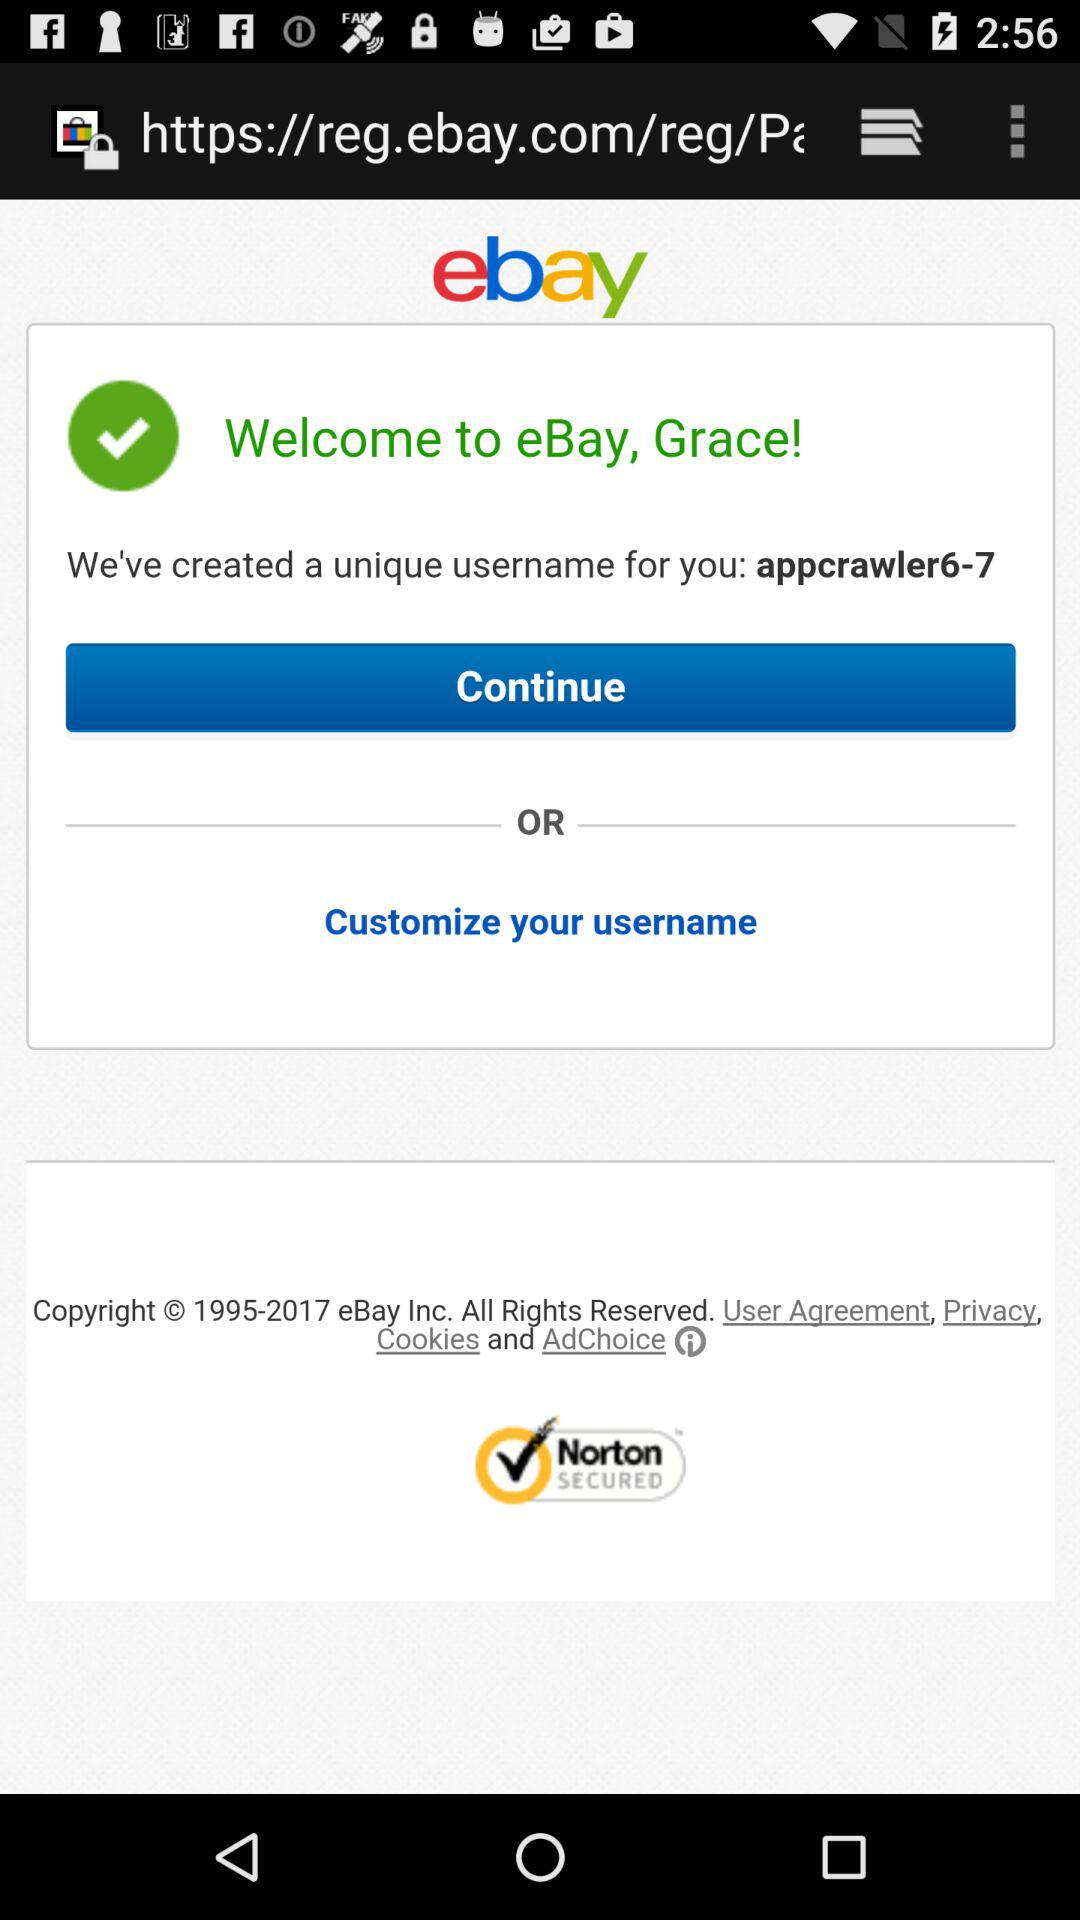What is a uniquely created username? A uniquely created username is "appcrawler6-7". 